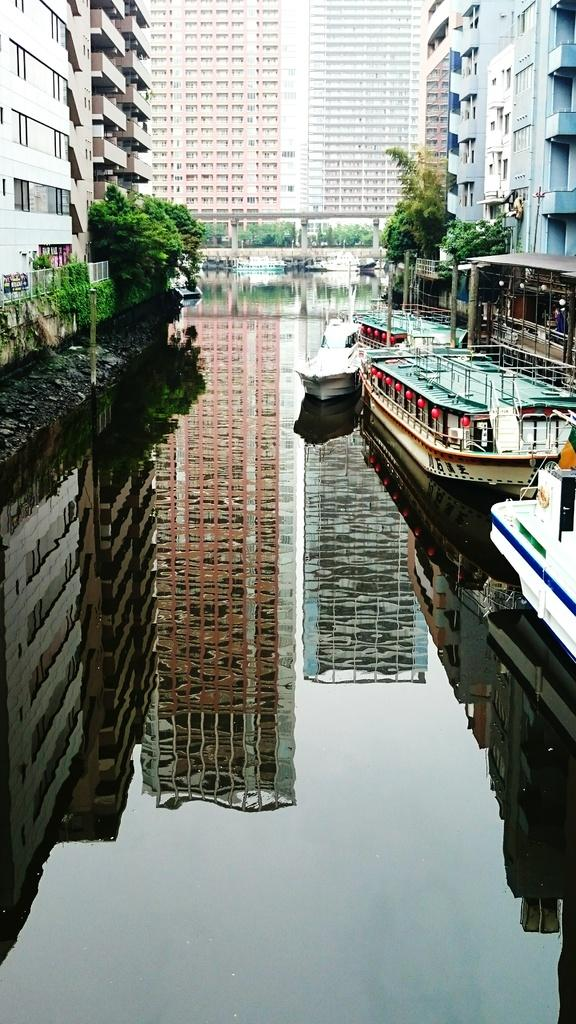What is in the foreground of the image? There are creepers and boats in the water in the foreground of the image. What can be seen in the background of the image? There are buildings, windows, a bridge, and trees in the background of the image. What time of day was the image taken? The image was taken during the day. How many ants can be seen carrying food on the bridge in the image? There are no ants visible in the image, let alone carrying food on the bridge. What type of clocks are present in the buildings in the background of the image? There is no mention of clocks in the image, so we cannot determine what type of clocks might be present in the buildings. 